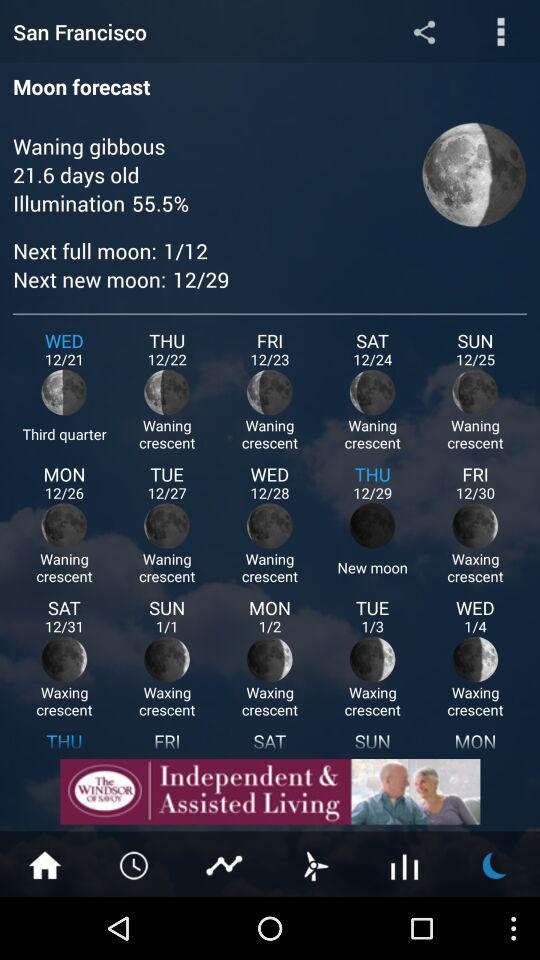What was the phase of the moon on 12/21? The phase of the moon was "Third quarter". 